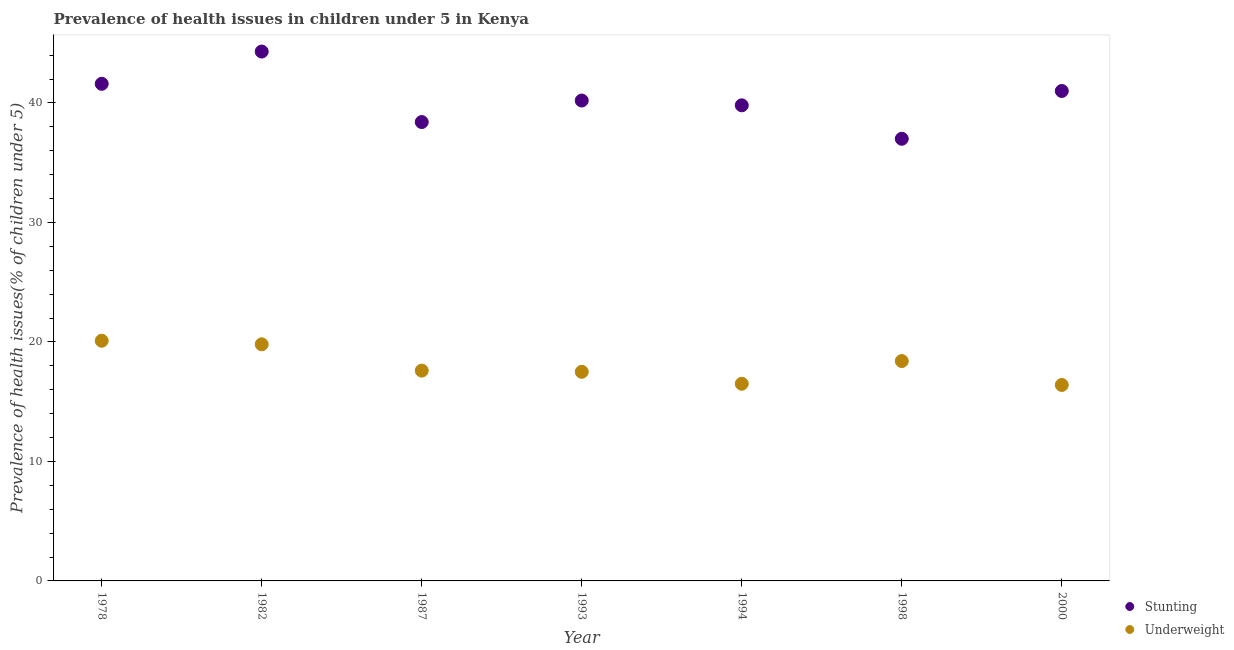How many different coloured dotlines are there?
Give a very brief answer. 2. Is the number of dotlines equal to the number of legend labels?
Your answer should be compact. Yes. What is the percentage of underweight children in 1982?
Your answer should be very brief. 19.8. Across all years, what is the maximum percentage of stunted children?
Offer a very short reply. 44.3. Across all years, what is the minimum percentage of stunted children?
Offer a very short reply. 37. In which year was the percentage of underweight children maximum?
Your response must be concise. 1978. In which year was the percentage of stunted children minimum?
Your response must be concise. 1998. What is the total percentage of stunted children in the graph?
Ensure brevity in your answer.  282.3. What is the difference between the percentage of underweight children in 1978 and that in 2000?
Keep it short and to the point. 3.7. What is the difference between the percentage of underweight children in 1994 and the percentage of stunted children in 2000?
Your answer should be very brief. -24.5. What is the average percentage of stunted children per year?
Your response must be concise. 40.33. In the year 1978, what is the difference between the percentage of stunted children and percentage of underweight children?
Provide a short and direct response. 21.5. What is the ratio of the percentage of underweight children in 1987 to that in 1993?
Your response must be concise. 1.01. What is the difference between the highest and the second highest percentage of underweight children?
Provide a short and direct response. 0.3. What is the difference between the highest and the lowest percentage of underweight children?
Your answer should be very brief. 3.7. In how many years, is the percentage of stunted children greater than the average percentage of stunted children taken over all years?
Give a very brief answer. 3. Is the sum of the percentage of stunted children in 1982 and 1998 greater than the maximum percentage of underweight children across all years?
Make the answer very short. Yes. Does the percentage of stunted children monotonically increase over the years?
Provide a succinct answer. No. Is the percentage of underweight children strictly less than the percentage of stunted children over the years?
Give a very brief answer. Yes. How many dotlines are there?
Make the answer very short. 2. What is the difference between two consecutive major ticks on the Y-axis?
Your answer should be compact. 10. Does the graph contain any zero values?
Keep it short and to the point. No. Where does the legend appear in the graph?
Give a very brief answer. Bottom right. What is the title of the graph?
Provide a succinct answer. Prevalence of health issues in children under 5 in Kenya. Does "Health Care" appear as one of the legend labels in the graph?
Your answer should be compact. No. What is the label or title of the Y-axis?
Your answer should be very brief. Prevalence of health issues(% of children under 5). What is the Prevalence of health issues(% of children under 5) in Stunting in 1978?
Ensure brevity in your answer.  41.6. What is the Prevalence of health issues(% of children under 5) in Underweight in 1978?
Offer a terse response. 20.1. What is the Prevalence of health issues(% of children under 5) of Stunting in 1982?
Keep it short and to the point. 44.3. What is the Prevalence of health issues(% of children under 5) of Underweight in 1982?
Your answer should be very brief. 19.8. What is the Prevalence of health issues(% of children under 5) in Stunting in 1987?
Offer a terse response. 38.4. What is the Prevalence of health issues(% of children under 5) of Underweight in 1987?
Your response must be concise. 17.6. What is the Prevalence of health issues(% of children under 5) of Stunting in 1993?
Provide a short and direct response. 40.2. What is the Prevalence of health issues(% of children under 5) in Stunting in 1994?
Ensure brevity in your answer.  39.8. What is the Prevalence of health issues(% of children under 5) in Underweight in 1998?
Provide a short and direct response. 18.4. What is the Prevalence of health issues(% of children under 5) of Underweight in 2000?
Keep it short and to the point. 16.4. Across all years, what is the maximum Prevalence of health issues(% of children under 5) of Stunting?
Provide a succinct answer. 44.3. Across all years, what is the maximum Prevalence of health issues(% of children under 5) in Underweight?
Offer a very short reply. 20.1. Across all years, what is the minimum Prevalence of health issues(% of children under 5) in Underweight?
Give a very brief answer. 16.4. What is the total Prevalence of health issues(% of children under 5) of Stunting in the graph?
Your answer should be compact. 282.3. What is the total Prevalence of health issues(% of children under 5) of Underweight in the graph?
Give a very brief answer. 126.3. What is the difference between the Prevalence of health issues(% of children under 5) of Stunting in 1978 and that in 1982?
Your answer should be very brief. -2.7. What is the difference between the Prevalence of health issues(% of children under 5) in Stunting in 1978 and that in 1993?
Your answer should be compact. 1.4. What is the difference between the Prevalence of health issues(% of children under 5) of Underweight in 1978 and that in 1994?
Provide a short and direct response. 3.6. What is the difference between the Prevalence of health issues(% of children under 5) of Stunting in 1978 and that in 1998?
Provide a succinct answer. 4.6. What is the difference between the Prevalence of health issues(% of children under 5) in Underweight in 1978 and that in 1998?
Your response must be concise. 1.7. What is the difference between the Prevalence of health issues(% of children under 5) in Stunting in 1978 and that in 2000?
Provide a short and direct response. 0.6. What is the difference between the Prevalence of health issues(% of children under 5) of Underweight in 1982 and that in 1987?
Your answer should be very brief. 2.2. What is the difference between the Prevalence of health issues(% of children under 5) in Underweight in 1982 and that in 1993?
Your answer should be compact. 2.3. What is the difference between the Prevalence of health issues(% of children under 5) in Stunting in 1982 and that in 1998?
Offer a very short reply. 7.3. What is the difference between the Prevalence of health issues(% of children under 5) of Underweight in 1982 and that in 1998?
Make the answer very short. 1.4. What is the difference between the Prevalence of health issues(% of children under 5) of Stunting in 1982 and that in 2000?
Offer a terse response. 3.3. What is the difference between the Prevalence of health issues(% of children under 5) in Stunting in 1987 and that in 1993?
Provide a succinct answer. -1.8. What is the difference between the Prevalence of health issues(% of children under 5) of Underweight in 1987 and that in 1993?
Offer a terse response. 0.1. What is the difference between the Prevalence of health issues(% of children under 5) in Underweight in 1987 and that in 1994?
Offer a terse response. 1.1. What is the difference between the Prevalence of health issues(% of children under 5) of Underweight in 1993 and that in 1994?
Ensure brevity in your answer.  1. What is the difference between the Prevalence of health issues(% of children under 5) of Stunting in 1993 and that in 1998?
Your answer should be compact. 3.2. What is the difference between the Prevalence of health issues(% of children under 5) of Underweight in 1993 and that in 1998?
Offer a very short reply. -0.9. What is the difference between the Prevalence of health issues(% of children under 5) of Stunting in 1993 and that in 2000?
Offer a terse response. -0.8. What is the difference between the Prevalence of health issues(% of children under 5) of Underweight in 1993 and that in 2000?
Offer a terse response. 1.1. What is the difference between the Prevalence of health issues(% of children under 5) in Underweight in 1994 and that in 1998?
Keep it short and to the point. -1.9. What is the difference between the Prevalence of health issues(% of children under 5) of Stunting in 1978 and the Prevalence of health issues(% of children under 5) of Underweight in 1982?
Offer a very short reply. 21.8. What is the difference between the Prevalence of health issues(% of children under 5) in Stunting in 1978 and the Prevalence of health issues(% of children under 5) in Underweight in 1993?
Give a very brief answer. 24.1. What is the difference between the Prevalence of health issues(% of children under 5) of Stunting in 1978 and the Prevalence of health issues(% of children under 5) of Underweight in 1994?
Give a very brief answer. 25.1. What is the difference between the Prevalence of health issues(% of children under 5) in Stunting in 1978 and the Prevalence of health issues(% of children under 5) in Underweight in 1998?
Your answer should be compact. 23.2. What is the difference between the Prevalence of health issues(% of children under 5) of Stunting in 1978 and the Prevalence of health issues(% of children under 5) of Underweight in 2000?
Give a very brief answer. 25.2. What is the difference between the Prevalence of health issues(% of children under 5) of Stunting in 1982 and the Prevalence of health issues(% of children under 5) of Underweight in 1987?
Offer a terse response. 26.7. What is the difference between the Prevalence of health issues(% of children under 5) of Stunting in 1982 and the Prevalence of health issues(% of children under 5) of Underweight in 1993?
Keep it short and to the point. 26.8. What is the difference between the Prevalence of health issues(% of children under 5) in Stunting in 1982 and the Prevalence of health issues(% of children under 5) in Underweight in 1994?
Provide a short and direct response. 27.8. What is the difference between the Prevalence of health issues(% of children under 5) in Stunting in 1982 and the Prevalence of health issues(% of children under 5) in Underweight in 1998?
Your response must be concise. 25.9. What is the difference between the Prevalence of health issues(% of children under 5) of Stunting in 1982 and the Prevalence of health issues(% of children under 5) of Underweight in 2000?
Offer a very short reply. 27.9. What is the difference between the Prevalence of health issues(% of children under 5) in Stunting in 1987 and the Prevalence of health issues(% of children under 5) in Underweight in 1993?
Keep it short and to the point. 20.9. What is the difference between the Prevalence of health issues(% of children under 5) in Stunting in 1987 and the Prevalence of health issues(% of children under 5) in Underweight in 1994?
Provide a short and direct response. 21.9. What is the difference between the Prevalence of health issues(% of children under 5) of Stunting in 1987 and the Prevalence of health issues(% of children under 5) of Underweight in 1998?
Your answer should be compact. 20. What is the difference between the Prevalence of health issues(% of children under 5) of Stunting in 1993 and the Prevalence of health issues(% of children under 5) of Underweight in 1994?
Offer a terse response. 23.7. What is the difference between the Prevalence of health issues(% of children under 5) in Stunting in 1993 and the Prevalence of health issues(% of children under 5) in Underweight in 1998?
Provide a short and direct response. 21.8. What is the difference between the Prevalence of health issues(% of children under 5) of Stunting in 1993 and the Prevalence of health issues(% of children under 5) of Underweight in 2000?
Offer a very short reply. 23.8. What is the difference between the Prevalence of health issues(% of children under 5) in Stunting in 1994 and the Prevalence of health issues(% of children under 5) in Underweight in 1998?
Provide a succinct answer. 21.4. What is the difference between the Prevalence of health issues(% of children under 5) in Stunting in 1994 and the Prevalence of health issues(% of children under 5) in Underweight in 2000?
Give a very brief answer. 23.4. What is the difference between the Prevalence of health issues(% of children under 5) in Stunting in 1998 and the Prevalence of health issues(% of children under 5) in Underweight in 2000?
Your response must be concise. 20.6. What is the average Prevalence of health issues(% of children under 5) in Stunting per year?
Provide a short and direct response. 40.33. What is the average Prevalence of health issues(% of children under 5) of Underweight per year?
Your answer should be compact. 18.04. In the year 1987, what is the difference between the Prevalence of health issues(% of children under 5) of Stunting and Prevalence of health issues(% of children under 5) of Underweight?
Make the answer very short. 20.8. In the year 1993, what is the difference between the Prevalence of health issues(% of children under 5) of Stunting and Prevalence of health issues(% of children under 5) of Underweight?
Ensure brevity in your answer.  22.7. In the year 1994, what is the difference between the Prevalence of health issues(% of children under 5) in Stunting and Prevalence of health issues(% of children under 5) in Underweight?
Your response must be concise. 23.3. In the year 1998, what is the difference between the Prevalence of health issues(% of children under 5) of Stunting and Prevalence of health issues(% of children under 5) of Underweight?
Offer a terse response. 18.6. In the year 2000, what is the difference between the Prevalence of health issues(% of children under 5) of Stunting and Prevalence of health issues(% of children under 5) of Underweight?
Provide a short and direct response. 24.6. What is the ratio of the Prevalence of health issues(% of children under 5) of Stunting in 1978 to that in 1982?
Offer a very short reply. 0.94. What is the ratio of the Prevalence of health issues(% of children under 5) of Underweight in 1978 to that in 1982?
Offer a very short reply. 1.02. What is the ratio of the Prevalence of health issues(% of children under 5) in Stunting in 1978 to that in 1987?
Your response must be concise. 1.08. What is the ratio of the Prevalence of health issues(% of children under 5) in Underweight in 1978 to that in 1987?
Your answer should be very brief. 1.14. What is the ratio of the Prevalence of health issues(% of children under 5) in Stunting in 1978 to that in 1993?
Your answer should be very brief. 1.03. What is the ratio of the Prevalence of health issues(% of children under 5) in Underweight in 1978 to that in 1993?
Keep it short and to the point. 1.15. What is the ratio of the Prevalence of health issues(% of children under 5) of Stunting in 1978 to that in 1994?
Give a very brief answer. 1.05. What is the ratio of the Prevalence of health issues(% of children under 5) of Underweight in 1978 to that in 1994?
Offer a very short reply. 1.22. What is the ratio of the Prevalence of health issues(% of children under 5) of Stunting in 1978 to that in 1998?
Your response must be concise. 1.12. What is the ratio of the Prevalence of health issues(% of children under 5) in Underweight in 1978 to that in 1998?
Offer a very short reply. 1.09. What is the ratio of the Prevalence of health issues(% of children under 5) of Stunting in 1978 to that in 2000?
Ensure brevity in your answer.  1.01. What is the ratio of the Prevalence of health issues(% of children under 5) in Underweight in 1978 to that in 2000?
Your answer should be very brief. 1.23. What is the ratio of the Prevalence of health issues(% of children under 5) of Stunting in 1982 to that in 1987?
Provide a short and direct response. 1.15. What is the ratio of the Prevalence of health issues(% of children under 5) in Underweight in 1982 to that in 1987?
Your response must be concise. 1.12. What is the ratio of the Prevalence of health issues(% of children under 5) of Stunting in 1982 to that in 1993?
Offer a very short reply. 1.1. What is the ratio of the Prevalence of health issues(% of children under 5) in Underweight in 1982 to that in 1993?
Make the answer very short. 1.13. What is the ratio of the Prevalence of health issues(% of children under 5) in Stunting in 1982 to that in 1994?
Provide a succinct answer. 1.11. What is the ratio of the Prevalence of health issues(% of children under 5) in Underweight in 1982 to that in 1994?
Offer a very short reply. 1.2. What is the ratio of the Prevalence of health issues(% of children under 5) of Stunting in 1982 to that in 1998?
Provide a succinct answer. 1.2. What is the ratio of the Prevalence of health issues(% of children under 5) of Underweight in 1982 to that in 1998?
Your answer should be compact. 1.08. What is the ratio of the Prevalence of health issues(% of children under 5) in Stunting in 1982 to that in 2000?
Your answer should be very brief. 1.08. What is the ratio of the Prevalence of health issues(% of children under 5) of Underweight in 1982 to that in 2000?
Make the answer very short. 1.21. What is the ratio of the Prevalence of health issues(% of children under 5) of Stunting in 1987 to that in 1993?
Your answer should be very brief. 0.96. What is the ratio of the Prevalence of health issues(% of children under 5) in Underweight in 1987 to that in 1993?
Give a very brief answer. 1.01. What is the ratio of the Prevalence of health issues(% of children under 5) of Stunting in 1987 to that in 1994?
Your response must be concise. 0.96. What is the ratio of the Prevalence of health issues(% of children under 5) in Underweight in 1987 to that in 1994?
Provide a short and direct response. 1.07. What is the ratio of the Prevalence of health issues(% of children under 5) of Stunting in 1987 to that in 1998?
Give a very brief answer. 1.04. What is the ratio of the Prevalence of health issues(% of children under 5) in Underweight in 1987 to that in 1998?
Give a very brief answer. 0.96. What is the ratio of the Prevalence of health issues(% of children under 5) in Stunting in 1987 to that in 2000?
Offer a terse response. 0.94. What is the ratio of the Prevalence of health issues(% of children under 5) in Underweight in 1987 to that in 2000?
Offer a very short reply. 1.07. What is the ratio of the Prevalence of health issues(% of children under 5) of Underweight in 1993 to that in 1994?
Your answer should be compact. 1.06. What is the ratio of the Prevalence of health issues(% of children under 5) of Stunting in 1993 to that in 1998?
Your answer should be compact. 1.09. What is the ratio of the Prevalence of health issues(% of children under 5) in Underweight in 1993 to that in 1998?
Provide a succinct answer. 0.95. What is the ratio of the Prevalence of health issues(% of children under 5) of Stunting in 1993 to that in 2000?
Offer a very short reply. 0.98. What is the ratio of the Prevalence of health issues(% of children under 5) of Underweight in 1993 to that in 2000?
Offer a very short reply. 1.07. What is the ratio of the Prevalence of health issues(% of children under 5) in Stunting in 1994 to that in 1998?
Offer a terse response. 1.08. What is the ratio of the Prevalence of health issues(% of children under 5) in Underweight in 1994 to that in 1998?
Your answer should be compact. 0.9. What is the ratio of the Prevalence of health issues(% of children under 5) of Stunting in 1994 to that in 2000?
Your answer should be compact. 0.97. What is the ratio of the Prevalence of health issues(% of children under 5) of Underweight in 1994 to that in 2000?
Your answer should be compact. 1.01. What is the ratio of the Prevalence of health issues(% of children under 5) in Stunting in 1998 to that in 2000?
Provide a succinct answer. 0.9. What is the ratio of the Prevalence of health issues(% of children under 5) of Underweight in 1998 to that in 2000?
Provide a succinct answer. 1.12. What is the difference between the highest and the second highest Prevalence of health issues(% of children under 5) in Stunting?
Offer a very short reply. 2.7. What is the difference between the highest and the lowest Prevalence of health issues(% of children under 5) in Stunting?
Ensure brevity in your answer.  7.3. 